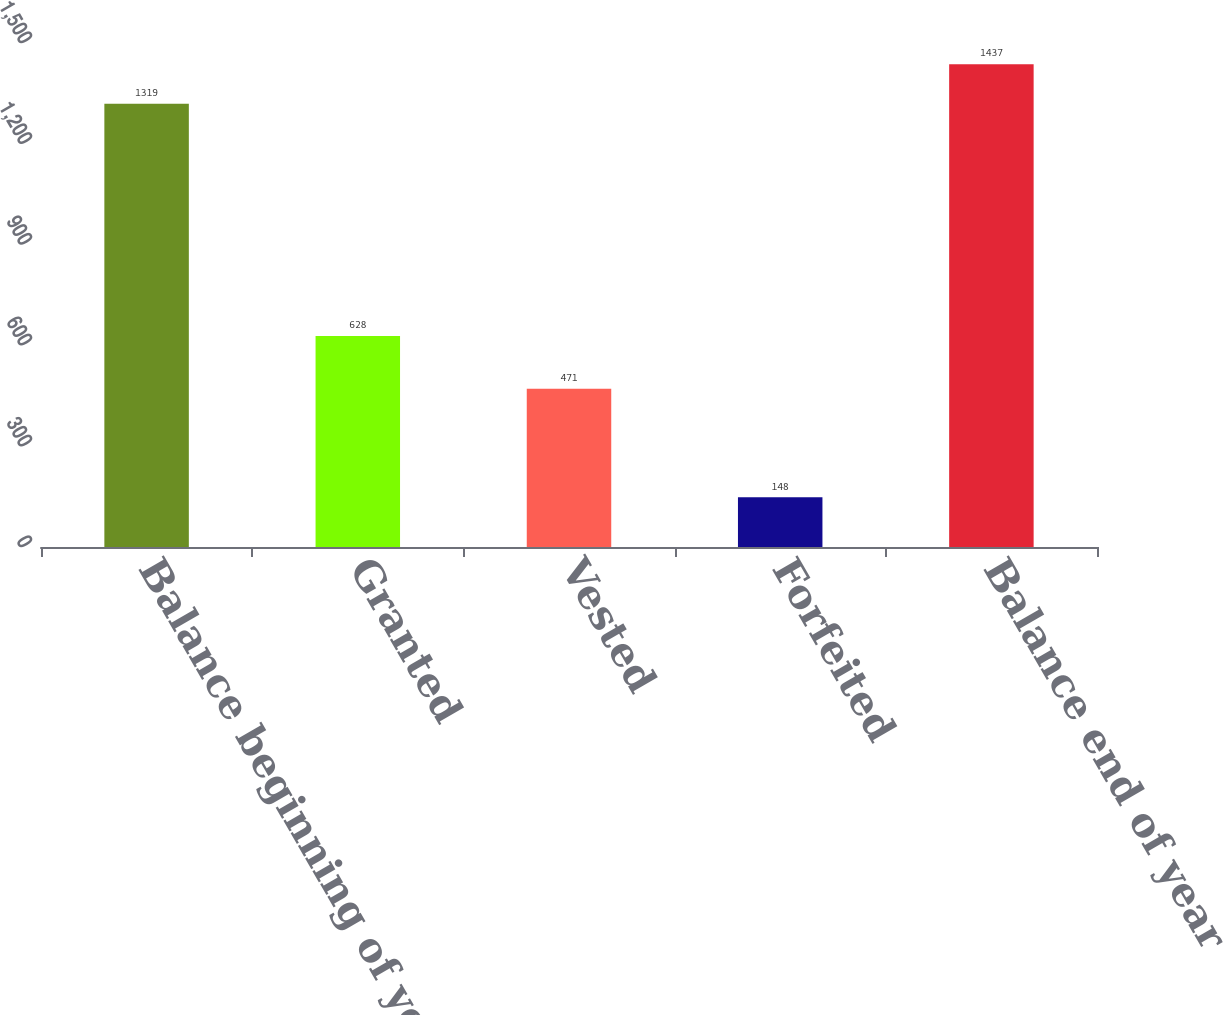<chart> <loc_0><loc_0><loc_500><loc_500><bar_chart><fcel>Balance beginning of year<fcel>Granted<fcel>Vested<fcel>Forfeited<fcel>Balance end of year<nl><fcel>1319<fcel>628<fcel>471<fcel>148<fcel>1437<nl></chart> 